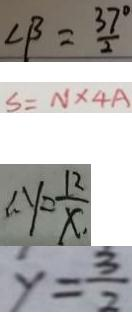Convert formula to latex. <formula><loc_0><loc_0><loc_500><loc_500>\angle \beta = \frac { 3 7 } { 2 } ^ { \circ } 
 S = N \times 4 A 
 \therefore y = \frac { 1 2 } { x . } 
 y = \frac { 3 } { 2 }</formula> 